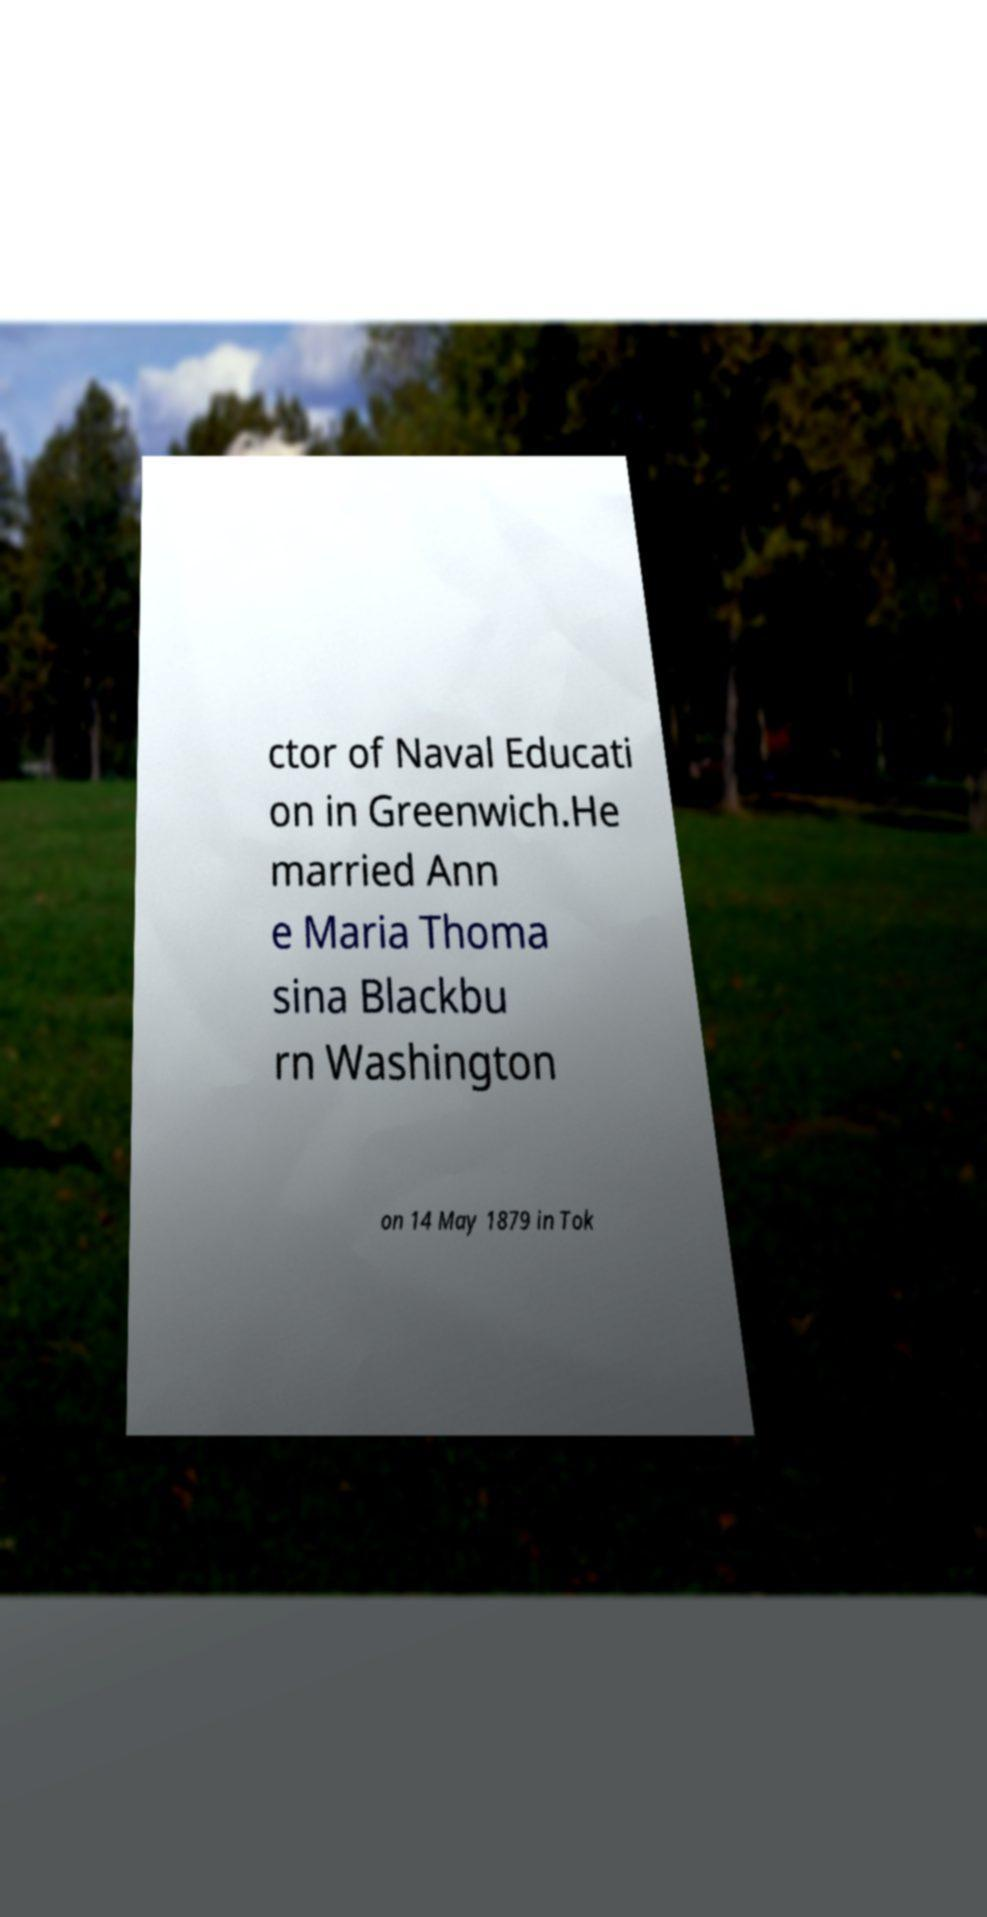Could you assist in decoding the text presented in this image and type it out clearly? ctor of Naval Educati on in Greenwich.He married Ann e Maria Thoma sina Blackbu rn Washington on 14 May 1879 in Tok 